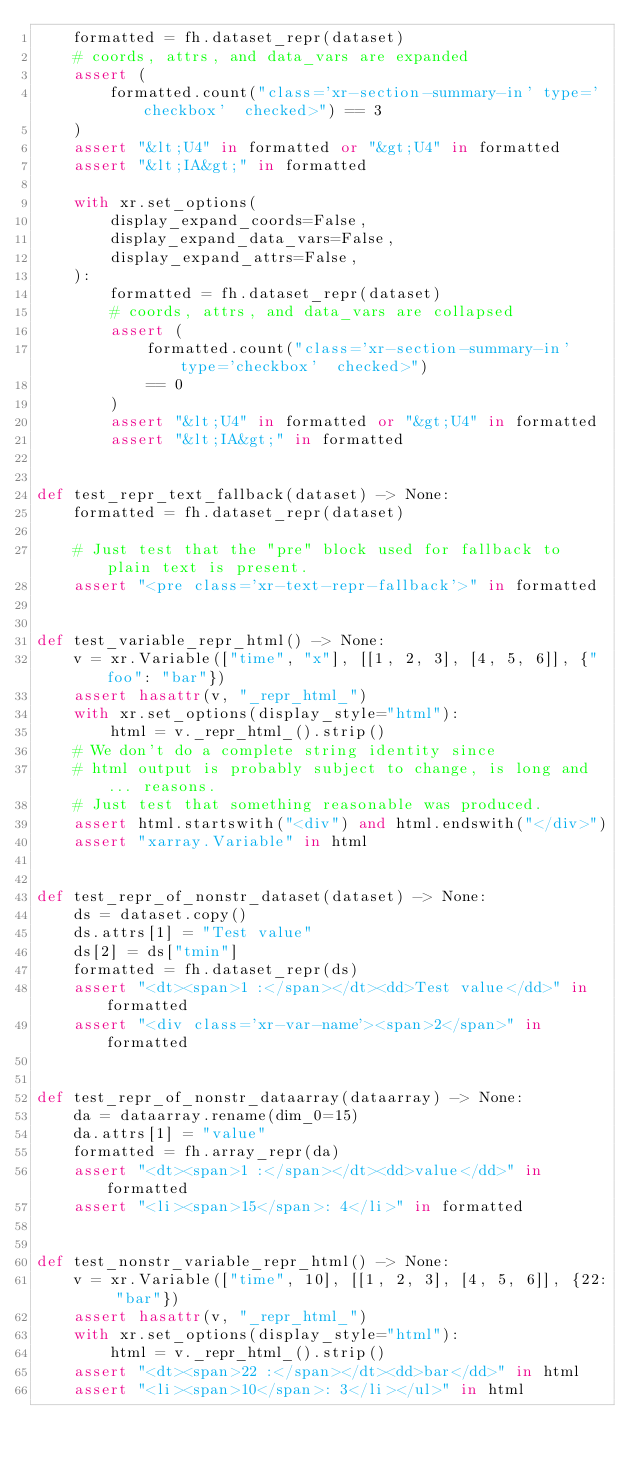<code> <loc_0><loc_0><loc_500><loc_500><_Python_>    formatted = fh.dataset_repr(dataset)
    # coords, attrs, and data_vars are expanded
    assert (
        formatted.count("class='xr-section-summary-in' type='checkbox'  checked>") == 3
    )
    assert "&lt;U4" in formatted or "&gt;U4" in formatted
    assert "&lt;IA&gt;" in formatted

    with xr.set_options(
        display_expand_coords=False,
        display_expand_data_vars=False,
        display_expand_attrs=False,
    ):
        formatted = fh.dataset_repr(dataset)
        # coords, attrs, and data_vars are collapsed
        assert (
            formatted.count("class='xr-section-summary-in' type='checkbox'  checked>")
            == 0
        )
        assert "&lt;U4" in formatted or "&gt;U4" in formatted
        assert "&lt;IA&gt;" in formatted


def test_repr_text_fallback(dataset) -> None:
    formatted = fh.dataset_repr(dataset)

    # Just test that the "pre" block used for fallback to plain text is present.
    assert "<pre class='xr-text-repr-fallback'>" in formatted


def test_variable_repr_html() -> None:
    v = xr.Variable(["time", "x"], [[1, 2, 3], [4, 5, 6]], {"foo": "bar"})
    assert hasattr(v, "_repr_html_")
    with xr.set_options(display_style="html"):
        html = v._repr_html_().strip()
    # We don't do a complete string identity since
    # html output is probably subject to change, is long and... reasons.
    # Just test that something reasonable was produced.
    assert html.startswith("<div") and html.endswith("</div>")
    assert "xarray.Variable" in html


def test_repr_of_nonstr_dataset(dataset) -> None:
    ds = dataset.copy()
    ds.attrs[1] = "Test value"
    ds[2] = ds["tmin"]
    formatted = fh.dataset_repr(ds)
    assert "<dt><span>1 :</span></dt><dd>Test value</dd>" in formatted
    assert "<div class='xr-var-name'><span>2</span>" in formatted


def test_repr_of_nonstr_dataarray(dataarray) -> None:
    da = dataarray.rename(dim_0=15)
    da.attrs[1] = "value"
    formatted = fh.array_repr(da)
    assert "<dt><span>1 :</span></dt><dd>value</dd>" in formatted
    assert "<li><span>15</span>: 4</li>" in formatted


def test_nonstr_variable_repr_html() -> None:
    v = xr.Variable(["time", 10], [[1, 2, 3], [4, 5, 6]], {22: "bar"})
    assert hasattr(v, "_repr_html_")
    with xr.set_options(display_style="html"):
        html = v._repr_html_().strip()
    assert "<dt><span>22 :</span></dt><dd>bar</dd>" in html
    assert "<li><span>10</span>: 3</li></ul>" in html
</code> 